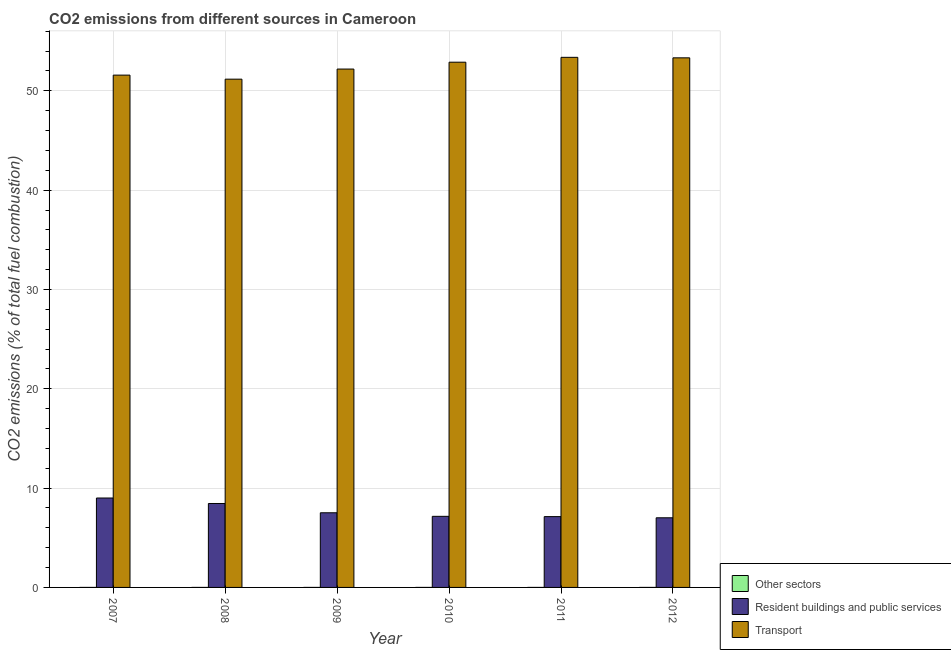How many different coloured bars are there?
Offer a terse response. 3. How many groups of bars are there?
Your answer should be compact. 6. Are the number of bars per tick equal to the number of legend labels?
Provide a succinct answer. Yes. Are the number of bars on each tick of the X-axis equal?
Make the answer very short. Yes. How many bars are there on the 3rd tick from the right?
Make the answer very short. 3. What is the label of the 5th group of bars from the left?
Make the answer very short. 2011. What is the percentage of co2 emissions from resident buildings and public services in 2011?
Keep it short and to the point. 7.13. Across all years, what is the maximum percentage of co2 emissions from transport?
Provide a short and direct response. 53.37. Across all years, what is the minimum percentage of co2 emissions from transport?
Your response must be concise. 51.17. In which year was the percentage of co2 emissions from other sectors minimum?
Your answer should be very brief. 2012. What is the total percentage of co2 emissions from other sectors in the graph?
Offer a very short reply. 1.095309852478697e-15. What is the difference between the percentage of co2 emissions from other sectors in 2007 and that in 2010?
Offer a very short reply. 3.859919794852999e-17. What is the difference between the percentage of co2 emissions from other sectors in 2011 and the percentage of co2 emissions from resident buildings and public services in 2012?
Provide a short and direct response. 7.091881198492007e-18. What is the average percentage of co2 emissions from other sectors per year?
Your response must be concise. 1.8255164207978285e-16. In the year 2010, what is the difference between the percentage of co2 emissions from transport and percentage of co2 emissions from resident buildings and public services?
Ensure brevity in your answer.  0. In how many years, is the percentage of co2 emissions from resident buildings and public services greater than 24 %?
Provide a succinct answer. 0. What is the ratio of the percentage of co2 emissions from resident buildings and public services in 2007 to that in 2008?
Your answer should be compact. 1.07. Is the difference between the percentage of co2 emissions from other sectors in 2008 and 2009 greater than the difference between the percentage of co2 emissions from transport in 2008 and 2009?
Your answer should be compact. No. What is the difference between the highest and the second highest percentage of co2 emissions from resident buildings and public services?
Your response must be concise. 0.55. What is the difference between the highest and the lowest percentage of co2 emissions from transport?
Make the answer very short. 2.2. Is the sum of the percentage of co2 emissions from other sectors in 2008 and 2010 greater than the maximum percentage of co2 emissions from resident buildings and public services across all years?
Ensure brevity in your answer.  Yes. What does the 1st bar from the left in 2009 represents?
Keep it short and to the point. Other sectors. What does the 1st bar from the right in 2009 represents?
Give a very brief answer. Transport. How many bars are there?
Give a very brief answer. 18. How many years are there in the graph?
Your answer should be very brief. 6. Does the graph contain any zero values?
Provide a short and direct response. No. Does the graph contain grids?
Offer a terse response. Yes. How many legend labels are there?
Keep it short and to the point. 3. How are the legend labels stacked?
Ensure brevity in your answer.  Vertical. What is the title of the graph?
Offer a very short reply. CO2 emissions from different sources in Cameroon. What is the label or title of the X-axis?
Provide a short and direct response. Year. What is the label or title of the Y-axis?
Keep it short and to the point. CO2 emissions (% of total fuel combustion). What is the CO2 emissions (% of total fuel combustion) in Other sectors in 2007?
Provide a succinct answer. 2.1103691921859e-16. What is the CO2 emissions (% of total fuel combustion) of Resident buildings and public services in 2007?
Offer a terse response. 9. What is the CO2 emissions (% of total fuel combustion) of Transport in 2007?
Offer a terse response. 51.58. What is the CO2 emissions (% of total fuel combustion) in Other sectors in 2008?
Make the answer very short. 2.03606041781315e-16. What is the CO2 emissions (% of total fuel combustion) in Resident buildings and public services in 2008?
Your answer should be compact. 8.45. What is the CO2 emissions (% of total fuel combustion) in Transport in 2008?
Provide a short and direct response. 51.17. What is the CO2 emissions (% of total fuel combustion) in Other sectors in 2009?
Your response must be concise. 1.810776070957e-16. What is the CO2 emissions (% of total fuel combustion) of Resident buildings and public services in 2009?
Ensure brevity in your answer.  7.52. What is the CO2 emissions (% of total fuel combustion) of Transport in 2009?
Your answer should be very brief. 52.19. What is the CO2 emissions (% of total fuel combustion) in Other sectors in 2010?
Your response must be concise. 1.7243772127006e-16. What is the CO2 emissions (% of total fuel combustion) in Resident buildings and public services in 2010?
Provide a succinct answer. 7.16. What is the CO2 emissions (% of total fuel combustion) of Transport in 2010?
Keep it short and to the point. 52.88. What is the CO2 emissions (% of total fuel combustion) in Other sectors in 2011?
Offer a terse response. 1.67121722155762e-16. What is the CO2 emissions (% of total fuel combustion) of Resident buildings and public services in 2011?
Ensure brevity in your answer.  7.13. What is the CO2 emissions (% of total fuel combustion) in Transport in 2011?
Keep it short and to the point. 53.37. What is the CO2 emissions (% of total fuel combustion) of Other sectors in 2012?
Your answer should be compact. 1.6002984095727e-16. What is the CO2 emissions (% of total fuel combustion) in Resident buildings and public services in 2012?
Make the answer very short. 7.01. What is the CO2 emissions (% of total fuel combustion) in Transport in 2012?
Your answer should be very brief. 53.32. Across all years, what is the maximum CO2 emissions (% of total fuel combustion) in Other sectors?
Ensure brevity in your answer.  2.1103691921859e-16. Across all years, what is the maximum CO2 emissions (% of total fuel combustion) of Resident buildings and public services?
Provide a short and direct response. 9. Across all years, what is the maximum CO2 emissions (% of total fuel combustion) in Transport?
Make the answer very short. 53.37. Across all years, what is the minimum CO2 emissions (% of total fuel combustion) in Other sectors?
Your response must be concise. 1.6002984095727e-16. Across all years, what is the minimum CO2 emissions (% of total fuel combustion) of Resident buildings and public services?
Give a very brief answer. 7.01. Across all years, what is the minimum CO2 emissions (% of total fuel combustion) of Transport?
Offer a very short reply. 51.17. What is the total CO2 emissions (% of total fuel combustion) in Resident buildings and public services in the graph?
Provide a short and direct response. 46.27. What is the total CO2 emissions (% of total fuel combustion) in Transport in the graph?
Provide a short and direct response. 314.52. What is the difference between the CO2 emissions (% of total fuel combustion) of Resident buildings and public services in 2007 and that in 2008?
Your answer should be very brief. 0.55. What is the difference between the CO2 emissions (% of total fuel combustion) in Transport in 2007 and that in 2008?
Provide a short and direct response. 0.41. What is the difference between the CO2 emissions (% of total fuel combustion) in Other sectors in 2007 and that in 2009?
Your response must be concise. 0. What is the difference between the CO2 emissions (% of total fuel combustion) of Resident buildings and public services in 2007 and that in 2009?
Provide a short and direct response. 1.49. What is the difference between the CO2 emissions (% of total fuel combustion) in Transport in 2007 and that in 2009?
Provide a succinct answer. -0.61. What is the difference between the CO2 emissions (% of total fuel combustion) in Resident buildings and public services in 2007 and that in 2010?
Your response must be concise. 1.85. What is the difference between the CO2 emissions (% of total fuel combustion) in Transport in 2007 and that in 2010?
Your response must be concise. -1.3. What is the difference between the CO2 emissions (% of total fuel combustion) in Other sectors in 2007 and that in 2011?
Your response must be concise. 0. What is the difference between the CO2 emissions (% of total fuel combustion) in Resident buildings and public services in 2007 and that in 2011?
Keep it short and to the point. 1.87. What is the difference between the CO2 emissions (% of total fuel combustion) in Transport in 2007 and that in 2011?
Give a very brief answer. -1.79. What is the difference between the CO2 emissions (% of total fuel combustion) in Other sectors in 2007 and that in 2012?
Your answer should be very brief. 0. What is the difference between the CO2 emissions (% of total fuel combustion) in Resident buildings and public services in 2007 and that in 2012?
Give a very brief answer. 1.99. What is the difference between the CO2 emissions (% of total fuel combustion) in Transport in 2007 and that in 2012?
Your answer should be very brief. -1.74. What is the difference between the CO2 emissions (% of total fuel combustion) of Other sectors in 2008 and that in 2009?
Provide a succinct answer. 0. What is the difference between the CO2 emissions (% of total fuel combustion) of Resident buildings and public services in 2008 and that in 2009?
Your answer should be compact. 0.94. What is the difference between the CO2 emissions (% of total fuel combustion) of Transport in 2008 and that in 2009?
Your response must be concise. -1.02. What is the difference between the CO2 emissions (% of total fuel combustion) of Resident buildings and public services in 2008 and that in 2010?
Give a very brief answer. 1.29. What is the difference between the CO2 emissions (% of total fuel combustion) in Transport in 2008 and that in 2010?
Offer a terse response. -1.71. What is the difference between the CO2 emissions (% of total fuel combustion) in Other sectors in 2008 and that in 2011?
Your answer should be very brief. 0. What is the difference between the CO2 emissions (% of total fuel combustion) in Resident buildings and public services in 2008 and that in 2011?
Provide a succinct answer. 1.32. What is the difference between the CO2 emissions (% of total fuel combustion) in Transport in 2008 and that in 2011?
Give a very brief answer. -2.2. What is the difference between the CO2 emissions (% of total fuel combustion) of Other sectors in 2008 and that in 2012?
Your answer should be very brief. 0. What is the difference between the CO2 emissions (% of total fuel combustion) in Resident buildings and public services in 2008 and that in 2012?
Your answer should be very brief. 1.44. What is the difference between the CO2 emissions (% of total fuel combustion) of Transport in 2008 and that in 2012?
Your answer should be very brief. -2.15. What is the difference between the CO2 emissions (% of total fuel combustion) in Other sectors in 2009 and that in 2010?
Provide a short and direct response. 0. What is the difference between the CO2 emissions (% of total fuel combustion) in Resident buildings and public services in 2009 and that in 2010?
Keep it short and to the point. 0.36. What is the difference between the CO2 emissions (% of total fuel combustion) of Transport in 2009 and that in 2010?
Keep it short and to the point. -0.69. What is the difference between the CO2 emissions (% of total fuel combustion) in Resident buildings and public services in 2009 and that in 2011?
Your response must be concise. 0.39. What is the difference between the CO2 emissions (% of total fuel combustion) of Transport in 2009 and that in 2011?
Your answer should be compact. -1.18. What is the difference between the CO2 emissions (% of total fuel combustion) of Other sectors in 2009 and that in 2012?
Offer a terse response. 0. What is the difference between the CO2 emissions (% of total fuel combustion) in Resident buildings and public services in 2009 and that in 2012?
Provide a short and direct response. 0.5. What is the difference between the CO2 emissions (% of total fuel combustion) of Transport in 2009 and that in 2012?
Offer a very short reply. -1.13. What is the difference between the CO2 emissions (% of total fuel combustion) of Resident buildings and public services in 2010 and that in 2011?
Your answer should be compact. 0.03. What is the difference between the CO2 emissions (% of total fuel combustion) in Transport in 2010 and that in 2011?
Your response must be concise. -0.49. What is the difference between the CO2 emissions (% of total fuel combustion) in Other sectors in 2010 and that in 2012?
Keep it short and to the point. 0. What is the difference between the CO2 emissions (% of total fuel combustion) of Resident buildings and public services in 2010 and that in 2012?
Keep it short and to the point. 0.15. What is the difference between the CO2 emissions (% of total fuel combustion) in Transport in 2010 and that in 2012?
Keep it short and to the point. -0.44. What is the difference between the CO2 emissions (% of total fuel combustion) of Other sectors in 2011 and that in 2012?
Your answer should be compact. 0. What is the difference between the CO2 emissions (% of total fuel combustion) in Resident buildings and public services in 2011 and that in 2012?
Ensure brevity in your answer.  0.12. What is the difference between the CO2 emissions (% of total fuel combustion) of Transport in 2011 and that in 2012?
Offer a terse response. 0.05. What is the difference between the CO2 emissions (% of total fuel combustion) in Other sectors in 2007 and the CO2 emissions (% of total fuel combustion) in Resident buildings and public services in 2008?
Ensure brevity in your answer.  -8.45. What is the difference between the CO2 emissions (% of total fuel combustion) in Other sectors in 2007 and the CO2 emissions (% of total fuel combustion) in Transport in 2008?
Offer a terse response. -51.17. What is the difference between the CO2 emissions (% of total fuel combustion) of Resident buildings and public services in 2007 and the CO2 emissions (% of total fuel combustion) of Transport in 2008?
Give a very brief answer. -42.17. What is the difference between the CO2 emissions (% of total fuel combustion) of Other sectors in 2007 and the CO2 emissions (% of total fuel combustion) of Resident buildings and public services in 2009?
Offer a terse response. -7.52. What is the difference between the CO2 emissions (% of total fuel combustion) of Other sectors in 2007 and the CO2 emissions (% of total fuel combustion) of Transport in 2009?
Ensure brevity in your answer.  -52.19. What is the difference between the CO2 emissions (% of total fuel combustion) in Resident buildings and public services in 2007 and the CO2 emissions (% of total fuel combustion) in Transport in 2009?
Provide a succinct answer. -43.19. What is the difference between the CO2 emissions (% of total fuel combustion) in Other sectors in 2007 and the CO2 emissions (% of total fuel combustion) in Resident buildings and public services in 2010?
Keep it short and to the point. -7.16. What is the difference between the CO2 emissions (% of total fuel combustion) of Other sectors in 2007 and the CO2 emissions (% of total fuel combustion) of Transport in 2010?
Your response must be concise. -52.88. What is the difference between the CO2 emissions (% of total fuel combustion) in Resident buildings and public services in 2007 and the CO2 emissions (% of total fuel combustion) in Transport in 2010?
Offer a very short reply. -43.88. What is the difference between the CO2 emissions (% of total fuel combustion) in Other sectors in 2007 and the CO2 emissions (% of total fuel combustion) in Resident buildings and public services in 2011?
Give a very brief answer. -7.13. What is the difference between the CO2 emissions (% of total fuel combustion) of Other sectors in 2007 and the CO2 emissions (% of total fuel combustion) of Transport in 2011?
Your answer should be very brief. -53.37. What is the difference between the CO2 emissions (% of total fuel combustion) in Resident buildings and public services in 2007 and the CO2 emissions (% of total fuel combustion) in Transport in 2011?
Provide a short and direct response. -44.37. What is the difference between the CO2 emissions (% of total fuel combustion) in Other sectors in 2007 and the CO2 emissions (% of total fuel combustion) in Resident buildings and public services in 2012?
Offer a very short reply. -7.01. What is the difference between the CO2 emissions (% of total fuel combustion) in Other sectors in 2007 and the CO2 emissions (% of total fuel combustion) in Transport in 2012?
Ensure brevity in your answer.  -53.32. What is the difference between the CO2 emissions (% of total fuel combustion) in Resident buildings and public services in 2007 and the CO2 emissions (% of total fuel combustion) in Transport in 2012?
Your answer should be compact. -44.32. What is the difference between the CO2 emissions (% of total fuel combustion) in Other sectors in 2008 and the CO2 emissions (% of total fuel combustion) in Resident buildings and public services in 2009?
Your answer should be very brief. -7.52. What is the difference between the CO2 emissions (% of total fuel combustion) of Other sectors in 2008 and the CO2 emissions (% of total fuel combustion) of Transport in 2009?
Provide a succinct answer. -52.19. What is the difference between the CO2 emissions (% of total fuel combustion) of Resident buildings and public services in 2008 and the CO2 emissions (% of total fuel combustion) of Transport in 2009?
Ensure brevity in your answer.  -43.74. What is the difference between the CO2 emissions (% of total fuel combustion) of Other sectors in 2008 and the CO2 emissions (% of total fuel combustion) of Resident buildings and public services in 2010?
Your response must be concise. -7.16. What is the difference between the CO2 emissions (% of total fuel combustion) in Other sectors in 2008 and the CO2 emissions (% of total fuel combustion) in Transport in 2010?
Provide a succinct answer. -52.88. What is the difference between the CO2 emissions (% of total fuel combustion) of Resident buildings and public services in 2008 and the CO2 emissions (% of total fuel combustion) of Transport in 2010?
Make the answer very short. -44.43. What is the difference between the CO2 emissions (% of total fuel combustion) of Other sectors in 2008 and the CO2 emissions (% of total fuel combustion) of Resident buildings and public services in 2011?
Provide a succinct answer. -7.13. What is the difference between the CO2 emissions (% of total fuel combustion) of Other sectors in 2008 and the CO2 emissions (% of total fuel combustion) of Transport in 2011?
Give a very brief answer. -53.37. What is the difference between the CO2 emissions (% of total fuel combustion) in Resident buildings and public services in 2008 and the CO2 emissions (% of total fuel combustion) in Transport in 2011?
Your answer should be compact. -44.92. What is the difference between the CO2 emissions (% of total fuel combustion) in Other sectors in 2008 and the CO2 emissions (% of total fuel combustion) in Resident buildings and public services in 2012?
Ensure brevity in your answer.  -7.01. What is the difference between the CO2 emissions (% of total fuel combustion) of Other sectors in 2008 and the CO2 emissions (% of total fuel combustion) of Transport in 2012?
Your response must be concise. -53.32. What is the difference between the CO2 emissions (% of total fuel combustion) in Resident buildings and public services in 2008 and the CO2 emissions (% of total fuel combustion) in Transport in 2012?
Your response must be concise. -44.87. What is the difference between the CO2 emissions (% of total fuel combustion) of Other sectors in 2009 and the CO2 emissions (% of total fuel combustion) of Resident buildings and public services in 2010?
Offer a terse response. -7.16. What is the difference between the CO2 emissions (% of total fuel combustion) in Other sectors in 2009 and the CO2 emissions (% of total fuel combustion) in Transport in 2010?
Your response must be concise. -52.88. What is the difference between the CO2 emissions (% of total fuel combustion) in Resident buildings and public services in 2009 and the CO2 emissions (% of total fuel combustion) in Transport in 2010?
Make the answer very short. -45.37. What is the difference between the CO2 emissions (% of total fuel combustion) in Other sectors in 2009 and the CO2 emissions (% of total fuel combustion) in Resident buildings and public services in 2011?
Provide a succinct answer. -7.13. What is the difference between the CO2 emissions (% of total fuel combustion) of Other sectors in 2009 and the CO2 emissions (% of total fuel combustion) of Transport in 2011?
Give a very brief answer. -53.37. What is the difference between the CO2 emissions (% of total fuel combustion) in Resident buildings and public services in 2009 and the CO2 emissions (% of total fuel combustion) in Transport in 2011?
Give a very brief answer. -45.86. What is the difference between the CO2 emissions (% of total fuel combustion) of Other sectors in 2009 and the CO2 emissions (% of total fuel combustion) of Resident buildings and public services in 2012?
Provide a succinct answer. -7.01. What is the difference between the CO2 emissions (% of total fuel combustion) of Other sectors in 2009 and the CO2 emissions (% of total fuel combustion) of Transport in 2012?
Your answer should be very brief. -53.32. What is the difference between the CO2 emissions (% of total fuel combustion) of Resident buildings and public services in 2009 and the CO2 emissions (% of total fuel combustion) of Transport in 2012?
Provide a succinct answer. -45.81. What is the difference between the CO2 emissions (% of total fuel combustion) in Other sectors in 2010 and the CO2 emissions (% of total fuel combustion) in Resident buildings and public services in 2011?
Your answer should be very brief. -7.13. What is the difference between the CO2 emissions (% of total fuel combustion) in Other sectors in 2010 and the CO2 emissions (% of total fuel combustion) in Transport in 2011?
Your response must be concise. -53.37. What is the difference between the CO2 emissions (% of total fuel combustion) in Resident buildings and public services in 2010 and the CO2 emissions (% of total fuel combustion) in Transport in 2011?
Give a very brief answer. -46.21. What is the difference between the CO2 emissions (% of total fuel combustion) of Other sectors in 2010 and the CO2 emissions (% of total fuel combustion) of Resident buildings and public services in 2012?
Keep it short and to the point. -7.01. What is the difference between the CO2 emissions (% of total fuel combustion) of Other sectors in 2010 and the CO2 emissions (% of total fuel combustion) of Transport in 2012?
Provide a succinct answer. -53.32. What is the difference between the CO2 emissions (% of total fuel combustion) in Resident buildings and public services in 2010 and the CO2 emissions (% of total fuel combustion) in Transport in 2012?
Provide a succinct answer. -46.16. What is the difference between the CO2 emissions (% of total fuel combustion) in Other sectors in 2011 and the CO2 emissions (% of total fuel combustion) in Resident buildings and public services in 2012?
Your response must be concise. -7.01. What is the difference between the CO2 emissions (% of total fuel combustion) in Other sectors in 2011 and the CO2 emissions (% of total fuel combustion) in Transport in 2012?
Give a very brief answer. -53.32. What is the difference between the CO2 emissions (% of total fuel combustion) in Resident buildings and public services in 2011 and the CO2 emissions (% of total fuel combustion) in Transport in 2012?
Your answer should be compact. -46.19. What is the average CO2 emissions (% of total fuel combustion) of Other sectors per year?
Offer a terse response. 0. What is the average CO2 emissions (% of total fuel combustion) in Resident buildings and public services per year?
Your answer should be very brief. 7.71. What is the average CO2 emissions (% of total fuel combustion) in Transport per year?
Give a very brief answer. 52.42. In the year 2007, what is the difference between the CO2 emissions (% of total fuel combustion) in Other sectors and CO2 emissions (% of total fuel combustion) in Resident buildings and public services?
Offer a very short reply. -9. In the year 2007, what is the difference between the CO2 emissions (% of total fuel combustion) of Other sectors and CO2 emissions (% of total fuel combustion) of Transport?
Provide a short and direct response. -51.58. In the year 2007, what is the difference between the CO2 emissions (% of total fuel combustion) in Resident buildings and public services and CO2 emissions (% of total fuel combustion) in Transport?
Ensure brevity in your answer.  -42.58. In the year 2008, what is the difference between the CO2 emissions (% of total fuel combustion) of Other sectors and CO2 emissions (% of total fuel combustion) of Resident buildings and public services?
Ensure brevity in your answer.  -8.45. In the year 2008, what is the difference between the CO2 emissions (% of total fuel combustion) in Other sectors and CO2 emissions (% of total fuel combustion) in Transport?
Your response must be concise. -51.17. In the year 2008, what is the difference between the CO2 emissions (% of total fuel combustion) in Resident buildings and public services and CO2 emissions (% of total fuel combustion) in Transport?
Provide a succinct answer. -42.72. In the year 2009, what is the difference between the CO2 emissions (% of total fuel combustion) in Other sectors and CO2 emissions (% of total fuel combustion) in Resident buildings and public services?
Offer a very short reply. -7.52. In the year 2009, what is the difference between the CO2 emissions (% of total fuel combustion) in Other sectors and CO2 emissions (% of total fuel combustion) in Transport?
Give a very brief answer. -52.19. In the year 2009, what is the difference between the CO2 emissions (% of total fuel combustion) of Resident buildings and public services and CO2 emissions (% of total fuel combustion) of Transport?
Make the answer very short. -44.68. In the year 2010, what is the difference between the CO2 emissions (% of total fuel combustion) of Other sectors and CO2 emissions (% of total fuel combustion) of Resident buildings and public services?
Your answer should be compact. -7.16. In the year 2010, what is the difference between the CO2 emissions (% of total fuel combustion) of Other sectors and CO2 emissions (% of total fuel combustion) of Transport?
Give a very brief answer. -52.88. In the year 2010, what is the difference between the CO2 emissions (% of total fuel combustion) of Resident buildings and public services and CO2 emissions (% of total fuel combustion) of Transport?
Give a very brief answer. -45.73. In the year 2011, what is the difference between the CO2 emissions (% of total fuel combustion) of Other sectors and CO2 emissions (% of total fuel combustion) of Resident buildings and public services?
Offer a terse response. -7.13. In the year 2011, what is the difference between the CO2 emissions (% of total fuel combustion) of Other sectors and CO2 emissions (% of total fuel combustion) of Transport?
Offer a very short reply. -53.37. In the year 2011, what is the difference between the CO2 emissions (% of total fuel combustion) of Resident buildings and public services and CO2 emissions (% of total fuel combustion) of Transport?
Offer a very short reply. -46.24. In the year 2012, what is the difference between the CO2 emissions (% of total fuel combustion) of Other sectors and CO2 emissions (% of total fuel combustion) of Resident buildings and public services?
Your answer should be very brief. -7.01. In the year 2012, what is the difference between the CO2 emissions (% of total fuel combustion) of Other sectors and CO2 emissions (% of total fuel combustion) of Transport?
Offer a very short reply. -53.32. In the year 2012, what is the difference between the CO2 emissions (% of total fuel combustion) in Resident buildings and public services and CO2 emissions (% of total fuel combustion) in Transport?
Provide a succinct answer. -46.31. What is the ratio of the CO2 emissions (% of total fuel combustion) in Other sectors in 2007 to that in 2008?
Provide a short and direct response. 1.04. What is the ratio of the CO2 emissions (% of total fuel combustion) in Resident buildings and public services in 2007 to that in 2008?
Ensure brevity in your answer.  1.07. What is the ratio of the CO2 emissions (% of total fuel combustion) of Other sectors in 2007 to that in 2009?
Ensure brevity in your answer.  1.17. What is the ratio of the CO2 emissions (% of total fuel combustion) in Resident buildings and public services in 2007 to that in 2009?
Make the answer very short. 1.2. What is the ratio of the CO2 emissions (% of total fuel combustion) of Transport in 2007 to that in 2009?
Your response must be concise. 0.99. What is the ratio of the CO2 emissions (% of total fuel combustion) of Other sectors in 2007 to that in 2010?
Provide a succinct answer. 1.22. What is the ratio of the CO2 emissions (% of total fuel combustion) of Resident buildings and public services in 2007 to that in 2010?
Give a very brief answer. 1.26. What is the ratio of the CO2 emissions (% of total fuel combustion) of Transport in 2007 to that in 2010?
Make the answer very short. 0.98. What is the ratio of the CO2 emissions (% of total fuel combustion) of Other sectors in 2007 to that in 2011?
Ensure brevity in your answer.  1.26. What is the ratio of the CO2 emissions (% of total fuel combustion) in Resident buildings and public services in 2007 to that in 2011?
Keep it short and to the point. 1.26. What is the ratio of the CO2 emissions (% of total fuel combustion) in Transport in 2007 to that in 2011?
Make the answer very short. 0.97. What is the ratio of the CO2 emissions (% of total fuel combustion) in Other sectors in 2007 to that in 2012?
Ensure brevity in your answer.  1.32. What is the ratio of the CO2 emissions (% of total fuel combustion) in Resident buildings and public services in 2007 to that in 2012?
Offer a very short reply. 1.28. What is the ratio of the CO2 emissions (% of total fuel combustion) of Transport in 2007 to that in 2012?
Offer a terse response. 0.97. What is the ratio of the CO2 emissions (% of total fuel combustion) of Other sectors in 2008 to that in 2009?
Your answer should be very brief. 1.12. What is the ratio of the CO2 emissions (% of total fuel combustion) of Resident buildings and public services in 2008 to that in 2009?
Your answer should be very brief. 1.12. What is the ratio of the CO2 emissions (% of total fuel combustion) in Transport in 2008 to that in 2009?
Offer a terse response. 0.98. What is the ratio of the CO2 emissions (% of total fuel combustion) of Other sectors in 2008 to that in 2010?
Offer a very short reply. 1.18. What is the ratio of the CO2 emissions (% of total fuel combustion) of Resident buildings and public services in 2008 to that in 2010?
Ensure brevity in your answer.  1.18. What is the ratio of the CO2 emissions (% of total fuel combustion) in Transport in 2008 to that in 2010?
Provide a succinct answer. 0.97. What is the ratio of the CO2 emissions (% of total fuel combustion) in Other sectors in 2008 to that in 2011?
Your answer should be very brief. 1.22. What is the ratio of the CO2 emissions (% of total fuel combustion) in Resident buildings and public services in 2008 to that in 2011?
Offer a very short reply. 1.19. What is the ratio of the CO2 emissions (% of total fuel combustion) in Transport in 2008 to that in 2011?
Provide a succinct answer. 0.96. What is the ratio of the CO2 emissions (% of total fuel combustion) in Other sectors in 2008 to that in 2012?
Offer a terse response. 1.27. What is the ratio of the CO2 emissions (% of total fuel combustion) in Resident buildings and public services in 2008 to that in 2012?
Offer a very short reply. 1.21. What is the ratio of the CO2 emissions (% of total fuel combustion) of Transport in 2008 to that in 2012?
Your answer should be very brief. 0.96. What is the ratio of the CO2 emissions (% of total fuel combustion) in Other sectors in 2009 to that in 2010?
Your response must be concise. 1.05. What is the ratio of the CO2 emissions (% of total fuel combustion) in Resident buildings and public services in 2009 to that in 2010?
Provide a short and direct response. 1.05. What is the ratio of the CO2 emissions (% of total fuel combustion) of Transport in 2009 to that in 2010?
Give a very brief answer. 0.99. What is the ratio of the CO2 emissions (% of total fuel combustion) of Other sectors in 2009 to that in 2011?
Your response must be concise. 1.08. What is the ratio of the CO2 emissions (% of total fuel combustion) in Resident buildings and public services in 2009 to that in 2011?
Give a very brief answer. 1.05. What is the ratio of the CO2 emissions (% of total fuel combustion) in Transport in 2009 to that in 2011?
Your response must be concise. 0.98. What is the ratio of the CO2 emissions (% of total fuel combustion) in Other sectors in 2009 to that in 2012?
Ensure brevity in your answer.  1.13. What is the ratio of the CO2 emissions (% of total fuel combustion) in Resident buildings and public services in 2009 to that in 2012?
Ensure brevity in your answer.  1.07. What is the ratio of the CO2 emissions (% of total fuel combustion) of Transport in 2009 to that in 2012?
Your response must be concise. 0.98. What is the ratio of the CO2 emissions (% of total fuel combustion) of Other sectors in 2010 to that in 2011?
Provide a succinct answer. 1.03. What is the ratio of the CO2 emissions (% of total fuel combustion) in Transport in 2010 to that in 2011?
Make the answer very short. 0.99. What is the ratio of the CO2 emissions (% of total fuel combustion) of Other sectors in 2010 to that in 2012?
Offer a terse response. 1.08. What is the ratio of the CO2 emissions (% of total fuel combustion) of Resident buildings and public services in 2010 to that in 2012?
Your response must be concise. 1.02. What is the ratio of the CO2 emissions (% of total fuel combustion) of Transport in 2010 to that in 2012?
Provide a succinct answer. 0.99. What is the ratio of the CO2 emissions (% of total fuel combustion) in Other sectors in 2011 to that in 2012?
Your response must be concise. 1.04. What is the ratio of the CO2 emissions (% of total fuel combustion) in Resident buildings and public services in 2011 to that in 2012?
Offer a terse response. 1.02. What is the difference between the highest and the second highest CO2 emissions (% of total fuel combustion) in Resident buildings and public services?
Ensure brevity in your answer.  0.55. What is the difference between the highest and the second highest CO2 emissions (% of total fuel combustion) in Transport?
Provide a short and direct response. 0.05. What is the difference between the highest and the lowest CO2 emissions (% of total fuel combustion) of Other sectors?
Your answer should be compact. 0. What is the difference between the highest and the lowest CO2 emissions (% of total fuel combustion) of Resident buildings and public services?
Offer a very short reply. 1.99. What is the difference between the highest and the lowest CO2 emissions (% of total fuel combustion) of Transport?
Provide a short and direct response. 2.2. 